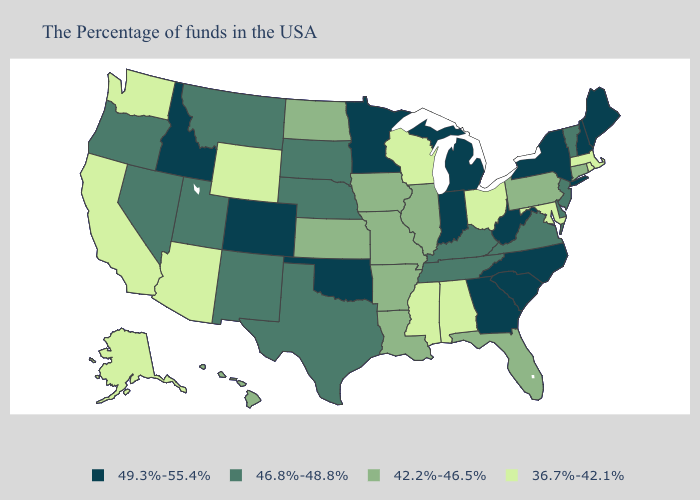Does the map have missing data?
Concise answer only. No. Name the states that have a value in the range 46.8%-48.8%?
Answer briefly. Vermont, New Jersey, Delaware, Virginia, Kentucky, Tennessee, Nebraska, Texas, South Dakota, New Mexico, Utah, Montana, Nevada, Oregon. Name the states that have a value in the range 46.8%-48.8%?
Quick response, please. Vermont, New Jersey, Delaware, Virginia, Kentucky, Tennessee, Nebraska, Texas, South Dakota, New Mexico, Utah, Montana, Nevada, Oregon. What is the lowest value in the MidWest?
Answer briefly. 36.7%-42.1%. What is the highest value in the USA?
Keep it brief. 49.3%-55.4%. What is the value of Hawaii?
Quick response, please. 42.2%-46.5%. Does the first symbol in the legend represent the smallest category?
Concise answer only. No. Does Iowa have the lowest value in the USA?
Write a very short answer. No. What is the lowest value in the USA?
Concise answer only. 36.7%-42.1%. What is the lowest value in the South?
Short answer required. 36.7%-42.1%. What is the highest value in the USA?
Quick response, please. 49.3%-55.4%. Does Michigan have the highest value in the MidWest?
Give a very brief answer. Yes. Which states have the highest value in the USA?
Be succinct. Maine, New Hampshire, New York, North Carolina, South Carolina, West Virginia, Georgia, Michigan, Indiana, Minnesota, Oklahoma, Colorado, Idaho. Name the states that have a value in the range 46.8%-48.8%?
Keep it brief. Vermont, New Jersey, Delaware, Virginia, Kentucky, Tennessee, Nebraska, Texas, South Dakota, New Mexico, Utah, Montana, Nevada, Oregon. Which states have the lowest value in the South?
Answer briefly. Maryland, Alabama, Mississippi. 